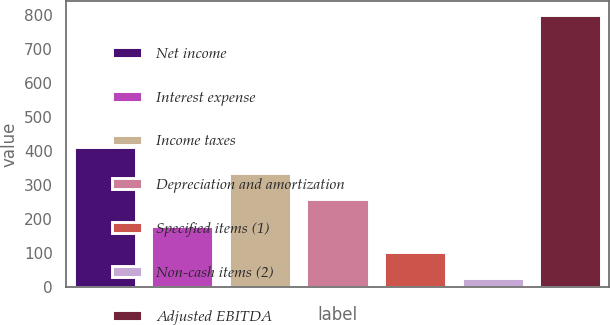<chart> <loc_0><loc_0><loc_500><loc_500><bar_chart><fcel>Net income<fcel>Interest expense<fcel>Income taxes<fcel>Depreciation and amortization<fcel>Specified items (1)<fcel>Non-cash items (2)<fcel>Adjusted EBITDA<nl><fcel>413.5<fcel>181.24<fcel>336.08<fcel>258.66<fcel>103.82<fcel>26.4<fcel>800.6<nl></chart> 